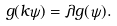Convert formula to latex. <formula><loc_0><loc_0><loc_500><loc_500>g ( k \psi ) = \lambda g ( \psi ) .</formula> 